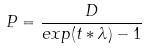<formula> <loc_0><loc_0><loc_500><loc_500>P = \frac { D } { e x p ( t * \lambda ) - 1 }</formula> 